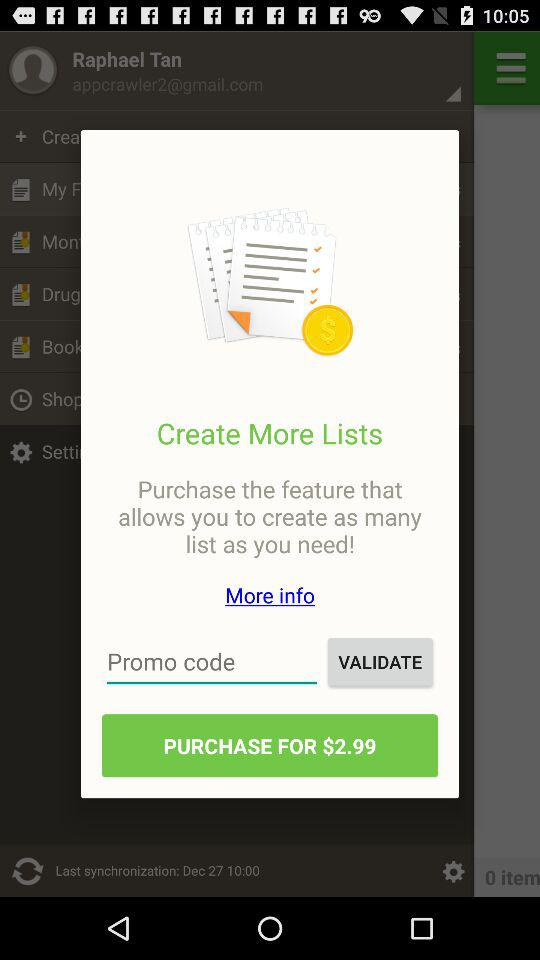Can we use promo code?
When the provided information is insufficient, respond with <no answer>. <no answer> 